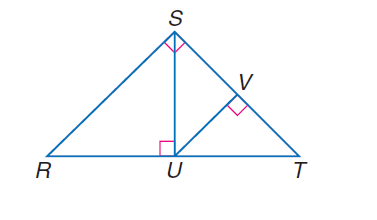Answer the mathemtical geometry problem and directly provide the correct option letter.
Question: If \angle R S T is a right angle, S U \perp R T, U V \perp S T, and m \angle R T S = 47, find m \angle T U V.
Choices: A: 37 B: 40 C: 43 D: 45 C 